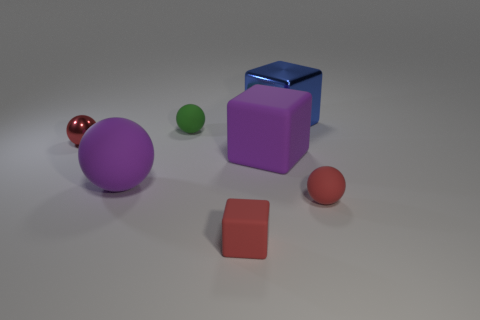The purple matte ball has what size?
Offer a terse response. Large. How many objects are either large gray metal cylinders or small green balls?
Make the answer very short. 1. The other small cube that is the same material as the purple block is what color?
Your response must be concise. Red. There is a tiny red thing to the left of the red matte block; does it have the same shape as the green thing?
Make the answer very short. Yes. How many things are either big purple rubber things left of the small matte cube or red balls to the right of the large blue metallic thing?
Keep it short and to the point. 2. What color is the other small matte thing that is the same shape as the blue thing?
Provide a succinct answer. Red. Is there any other thing that is the same shape as the red shiny object?
Offer a terse response. Yes. Does the blue thing have the same shape as the small red object that is behind the big purple rubber sphere?
Your answer should be very brief. No. What is the material of the green sphere?
Your response must be concise. Rubber. What size is the red matte thing that is the same shape as the blue metal object?
Give a very brief answer. Small. 